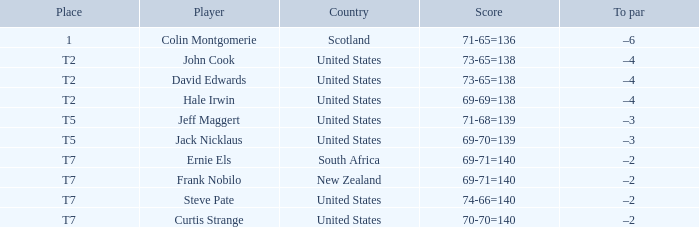What is the name of the golfer that has the score of 73-65=138? John Cook, David Edwards. 